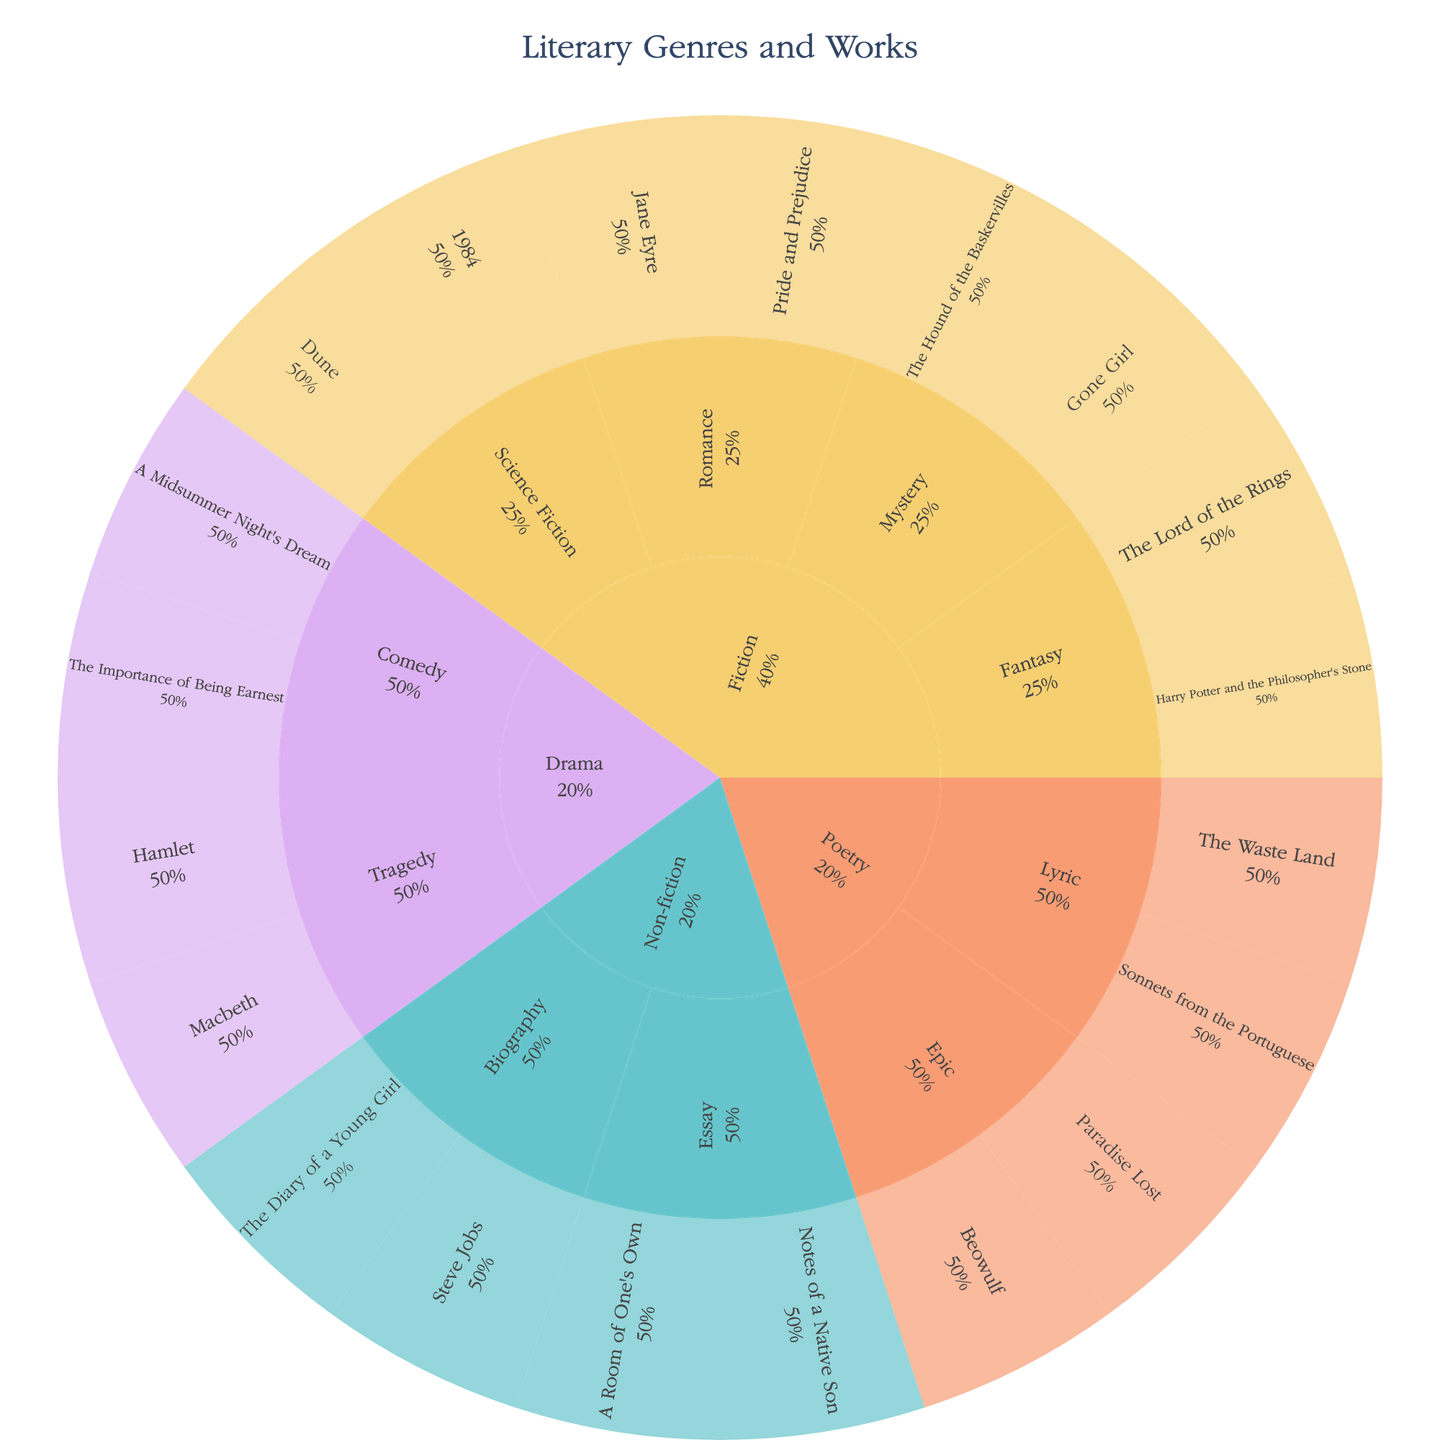What's the title of the sunburst plot? The title is displayed at the top of the figure.
Answer: Literary Genres and Works Which genre has the most subgenres? Scan the outer ring for genres and count the subgenres for each. Fiction has the most subgenres.
Answer: Fiction How many works are listed under the Non-fiction genre? Count all the works in the Non-fiction sections of the plot.
Answer: 4 What percentage of the Fiction genre is occupied by the Romance subgenre based on works? The sunburst plot shows percentages within each genre. Romance takes up about half of the Fiction genre segment.
Answer: 50% Which subgenre of Poetry contains the work "Paradise Lost"? Find "Paradise Lost" in the Poetry segment and trace it to its subgenre.
Answer: Epic Between Lyric Poetry and Epic Poetry, which subgenre has more works? Compare the number of works listed under Lyric and Epic Poetry. Lyric has 2, Epic has 2.
Answer: They have the same number of works Can you list two works found in the Drama genre under Comedy subgenre? Scan the Drama genre, then find the Comedy subgenre and list the works there.
Answer: A Midsummer Night's Dream, The Importance of Being Earnest What is the percentage representation of Fiction compared to the total works shown? The sunburst plot shows the percentage for each genre in the overall chart. Fiction is about half of the total.
Answer: 50% Which genre has the fewest works listed? Compare the genres by counting the works in each. Non-fiction has the fewest works.
Answer: Non-fiction 